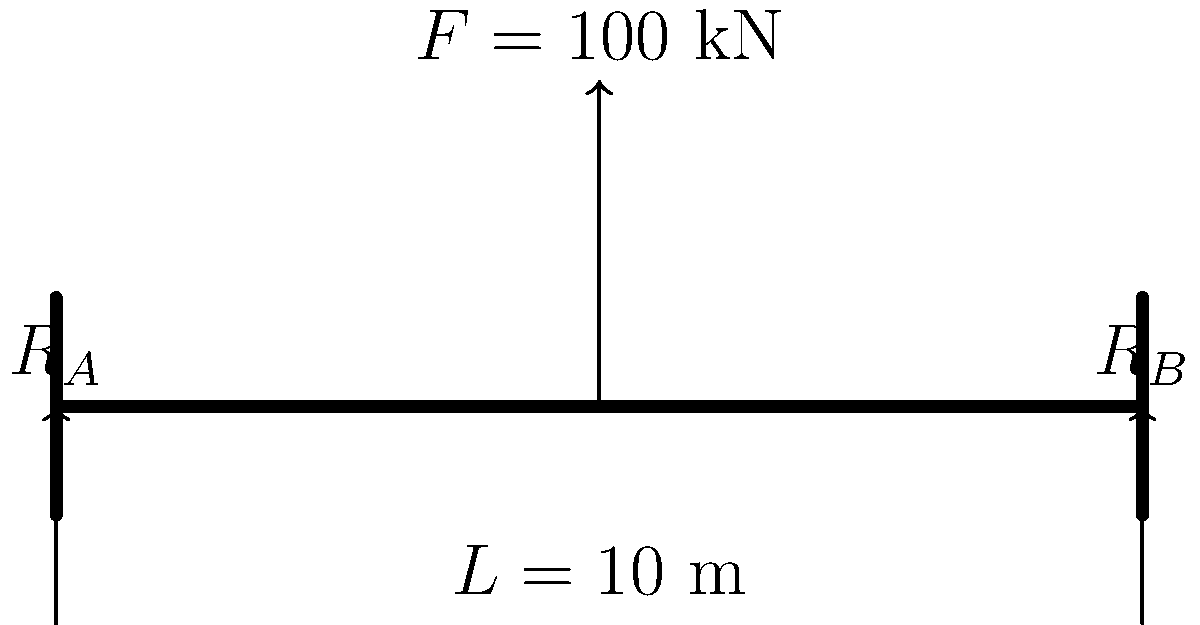A simple beam bridge spanning 10 meters is subjected to a point load of 100 kN at its midpoint. Assuming the bridge is perfectly symmetrical and the supports are identical, calculate the magnitude of the reaction forces $R_A$ and $R_B$ at the supports. Express your answer in kN. To solve this problem, we'll follow these steps:

1) First, recognize that this is a statically determinate problem. The sum of forces and moments must equal zero for the bridge to be in equilibrium.

2) Due to the symmetry of the bridge and the central location of the load, we can deduce that the reaction forces $R_A$ and $R_B$ will be equal.

3) Let's apply the principle of equilibrium of forces in the vertical direction:

   $$\sum F_y = 0$$
   $$R_A + R_B - F = 0$$
   $$R_A + R_B = 100 \text{ kN}$$

4) Given the symmetry, we know that:

   $$R_A = R_B$$

5) Substituting this into our equation:

   $$R_A + R_A = 100 \text{ kN}$$
   $$2R_A = 100 \text{ kN}$$

6) Solving for $R_A$:

   $$R_A = \frac{100 \text{ kN}}{2} = 50 \text{ kN}$$

7) Since $R_A = R_B$, we can conclude that $R_B$ is also 50 kN.

Therefore, each support bears half of the total load, which is 50 kN.
Answer: 50 kN 